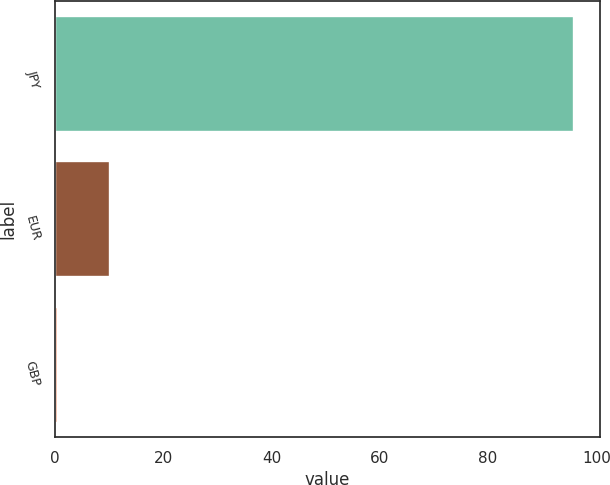<chart> <loc_0><loc_0><loc_500><loc_500><bar_chart><fcel>JPY<fcel>EUR<fcel>GBP<nl><fcel>95.86<fcel>10.16<fcel>0.64<nl></chart> 